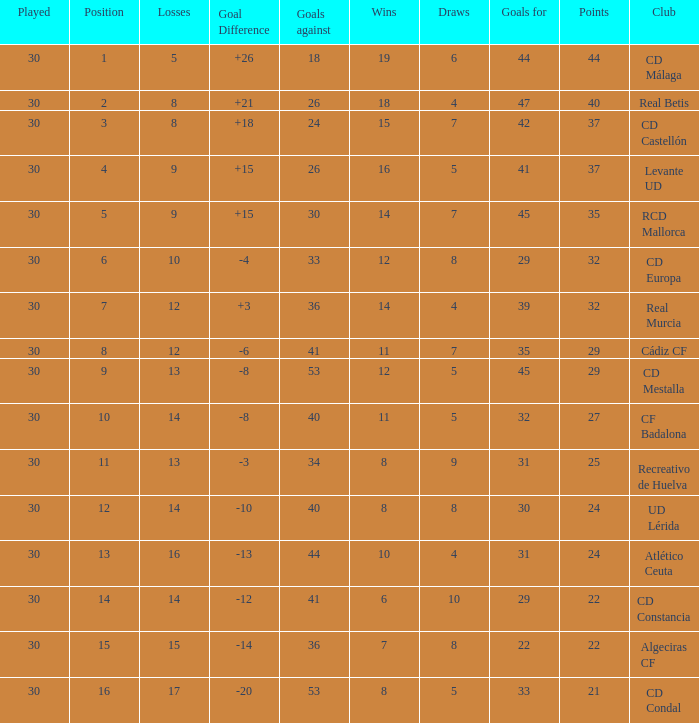What is the goals for when played is larger than 30? None. 